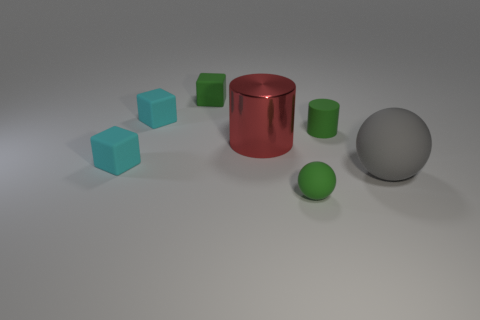Is there any other thing that is made of the same material as the big cylinder?
Your answer should be compact. No. There is a tiny green matte object that is on the right side of the tiny rubber sphere; is there a gray rubber thing that is to the left of it?
Give a very brief answer. No. There is another thing that is the same shape as the large red object; what material is it?
Give a very brief answer. Rubber. How many cyan cubes are right of the small green matte thing that is in front of the tiny green cylinder?
Offer a terse response. 0. Are there any other things that have the same color as the large cylinder?
Your answer should be compact. No. How many objects are metallic objects or big things that are on the left side of the gray object?
Ensure brevity in your answer.  1. There is a cyan thing behind the tiny matte cylinder behind the green thing that is in front of the large gray sphere; what is its material?
Your response must be concise. Rubber. What size is the cylinder that is made of the same material as the green sphere?
Give a very brief answer. Small. There is a big thing in front of the tiny cyan matte thing that is in front of the green rubber cylinder; what is its color?
Your answer should be compact. Gray. What number of small cyan cubes have the same material as the big red cylinder?
Provide a succinct answer. 0. 